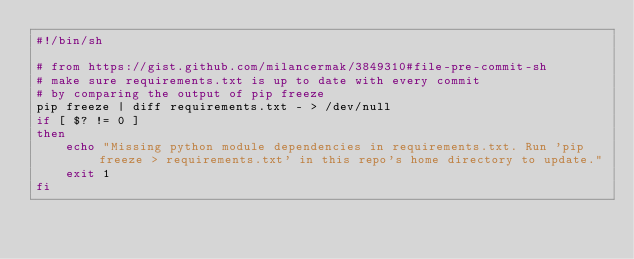Convert code to text. <code><loc_0><loc_0><loc_500><loc_500><_Bash_>#!/bin/sh

# from https://gist.github.com/milancermak/3849310#file-pre-commit-sh
# make sure requirements.txt is up to date with every commit
# by comparing the output of pip freeze
pip freeze | diff requirements.txt - > /dev/null
if [ $? != 0 ]
then
    echo "Missing python module dependencies in requirements.txt. Run 'pip freeze > requirements.txt' in this repo's home directory to update."
    exit 1
fi</code> 